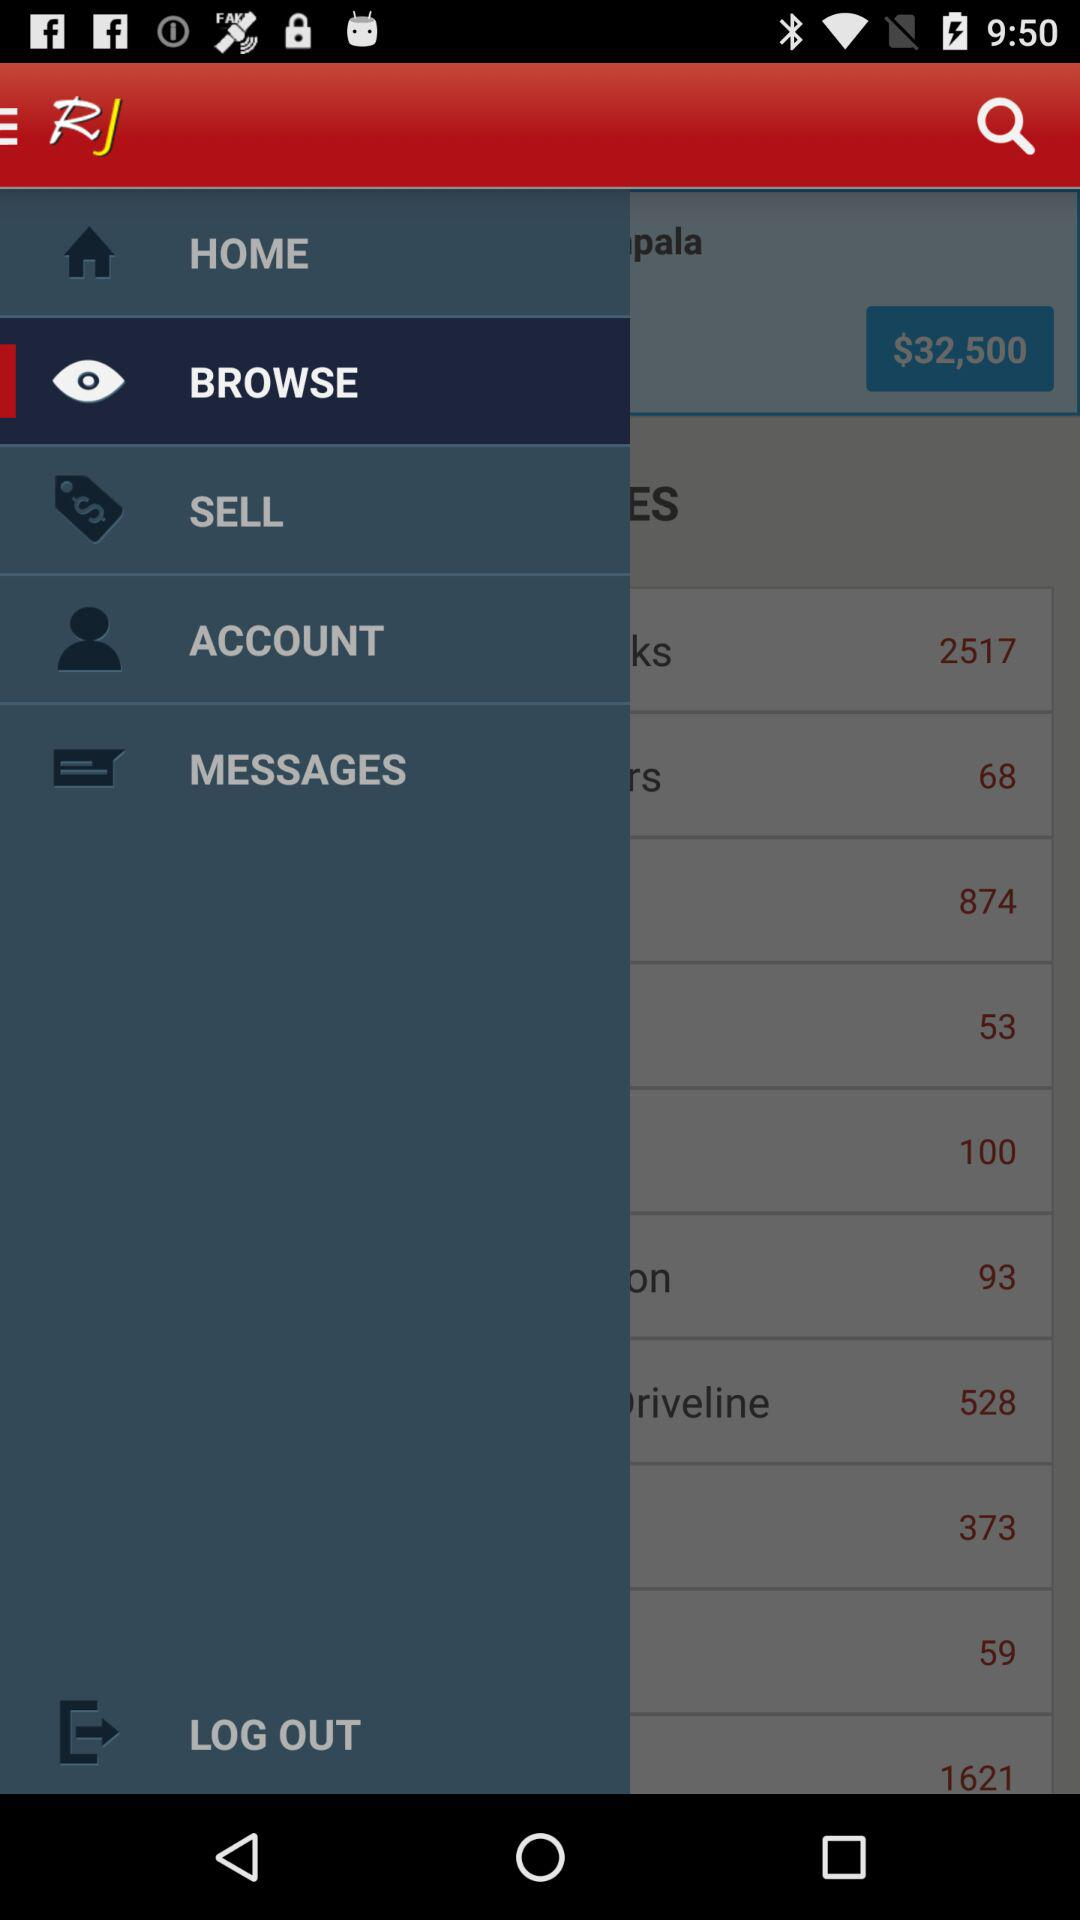Which number is larger, 32,500 or 874?
Answer the question using a single word or phrase. 32,500 